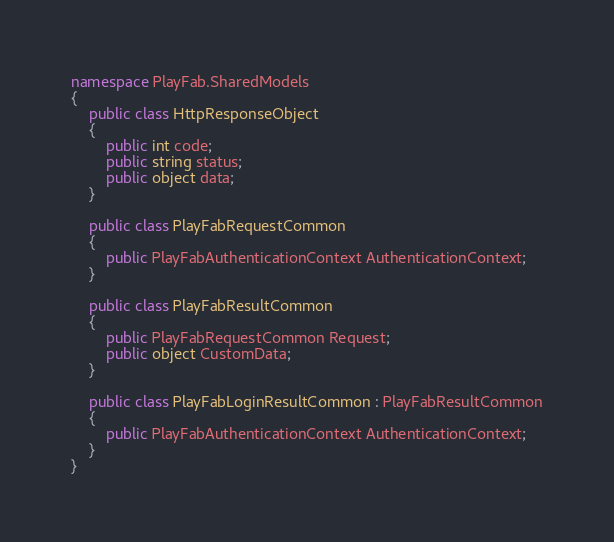<code> <loc_0><loc_0><loc_500><loc_500><_C#_>namespace PlayFab.SharedModels
{
    public class HttpResponseObject
    {
        public int code;
        public string status;
        public object data;
    }

    public class PlayFabRequestCommon
    {
        public PlayFabAuthenticationContext AuthenticationContext;
    }

    public class PlayFabResultCommon
    {
        public PlayFabRequestCommon Request;
        public object CustomData;
    }
    
    public class PlayFabLoginResultCommon : PlayFabResultCommon
    {
        public PlayFabAuthenticationContext AuthenticationContext;
    }
}
</code> 